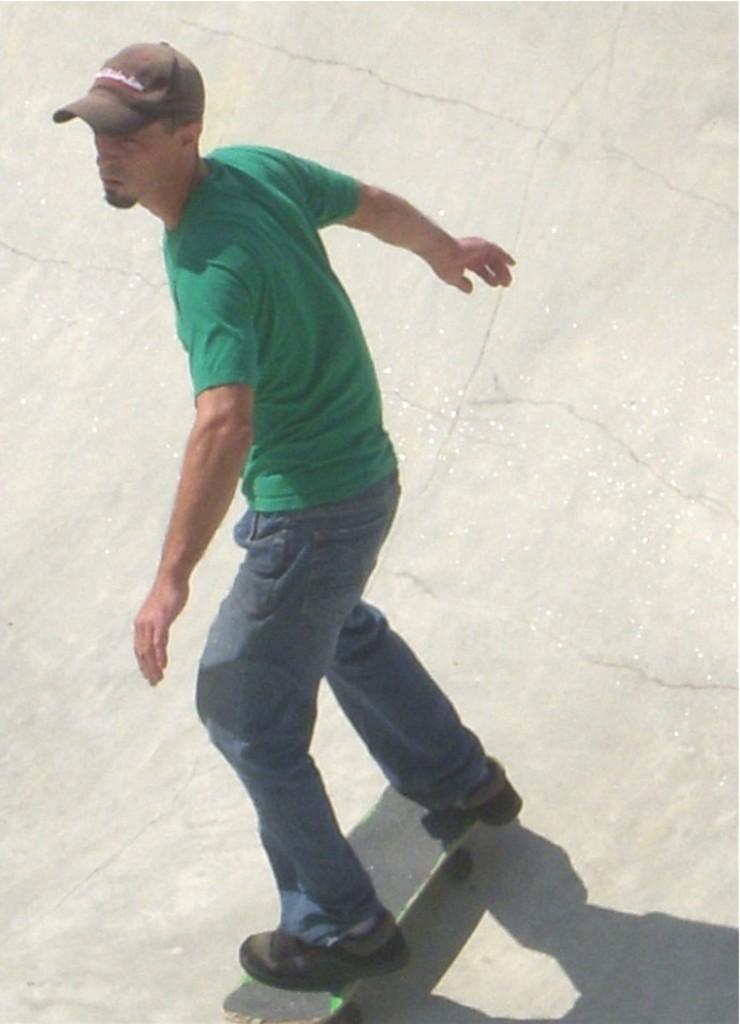Describe this image in one or two sentences. In this image we can see a person is skating, he is wearing a green color T-shirt, and a cap. 